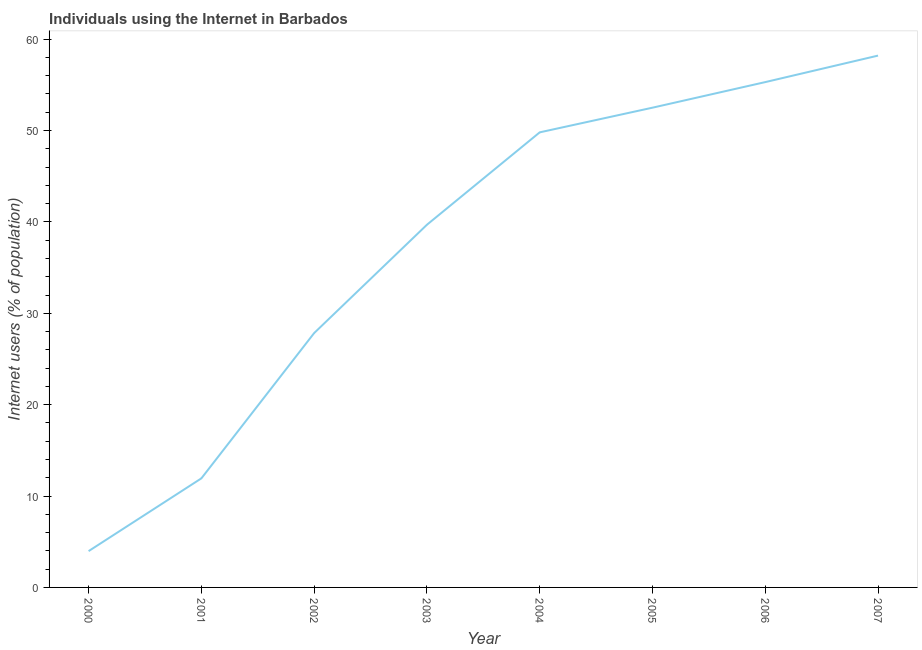What is the number of internet users in 2006?
Offer a very short reply. 55.3. Across all years, what is the maximum number of internet users?
Provide a succinct answer. 58.2. Across all years, what is the minimum number of internet users?
Provide a succinct answer. 3.97. In which year was the number of internet users maximum?
Make the answer very short. 2007. In which year was the number of internet users minimum?
Give a very brief answer. 2000. What is the sum of the number of internet users?
Give a very brief answer. 299.24. What is the difference between the number of internet users in 2001 and 2004?
Give a very brief answer. -37.86. What is the average number of internet users per year?
Offer a terse response. 37.4. What is the median number of internet users?
Your response must be concise. 44.74. In how many years, is the number of internet users greater than 8 %?
Keep it short and to the point. 7. What is the ratio of the number of internet users in 2002 to that in 2007?
Keep it short and to the point. 0.48. Is the number of internet users in 2000 less than that in 2002?
Keep it short and to the point. Yes. Is the difference between the number of internet users in 2004 and 2005 greater than the difference between any two years?
Make the answer very short. No. What is the difference between the highest and the second highest number of internet users?
Provide a short and direct response. 2.9. Is the sum of the number of internet users in 2004 and 2005 greater than the maximum number of internet users across all years?
Provide a short and direct response. Yes. What is the difference between the highest and the lowest number of internet users?
Your answer should be very brief. 54.23. Does the number of internet users monotonically increase over the years?
Your answer should be compact. Yes. How many lines are there?
Your response must be concise. 1. How many years are there in the graph?
Give a very brief answer. 8. Are the values on the major ticks of Y-axis written in scientific E-notation?
Keep it short and to the point. No. Does the graph contain grids?
Your response must be concise. No. What is the title of the graph?
Provide a short and direct response. Individuals using the Internet in Barbados. What is the label or title of the Y-axis?
Your answer should be compact. Internet users (% of population). What is the Internet users (% of population) in 2000?
Give a very brief answer. 3.97. What is the Internet users (% of population) in 2001?
Offer a very short reply. 11.94. What is the Internet users (% of population) of 2002?
Provide a succinct answer. 27.84. What is the Internet users (% of population) of 2003?
Make the answer very short. 39.69. What is the Internet users (% of population) in 2004?
Your response must be concise. 49.8. What is the Internet users (% of population) in 2005?
Keep it short and to the point. 52.5. What is the Internet users (% of population) in 2006?
Your answer should be compact. 55.3. What is the Internet users (% of population) of 2007?
Offer a terse response. 58.2. What is the difference between the Internet users (% of population) in 2000 and 2001?
Give a very brief answer. -7.96. What is the difference between the Internet users (% of population) in 2000 and 2002?
Ensure brevity in your answer.  -23.86. What is the difference between the Internet users (% of population) in 2000 and 2003?
Provide a short and direct response. -35.72. What is the difference between the Internet users (% of population) in 2000 and 2004?
Give a very brief answer. -45.83. What is the difference between the Internet users (% of population) in 2000 and 2005?
Your answer should be compact. -48.53. What is the difference between the Internet users (% of population) in 2000 and 2006?
Your answer should be very brief. -51.33. What is the difference between the Internet users (% of population) in 2000 and 2007?
Ensure brevity in your answer.  -54.23. What is the difference between the Internet users (% of population) in 2001 and 2002?
Your response must be concise. -15.9. What is the difference between the Internet users (% of population) in 2001 and 2003?
Make the answer very short. -27.75. What is the difference between the Internet users (% of population) in 2001 and 2004?
Your answer should be compact. -37.86. What is the difference between the Internet users (% of population) in 2001 and 2005?
Give a very brief answer. -40.56. What is the difference between the Internet users (% of population) in 2001 and 2006?
Provide a succinct answer. -43.36. What is the difference between the Internet users (% of population) in 2001 and 2007?
Make the answer very short. -46.26. What is the difference between the Internet users (% of population) in 2002 and 2003?
Provide a short and direct response. -11.85. What is the difference between the Internet users (% of population) in 2002 and 2004?
Your answer should be very brief. -21.96. What is the difference between the Internet users (% of population) in 2002 and 2005?
Your answer should be compact. -24.66. What is the difference between the Internet users (% of population) in 2002 and 2006?
Keep it short and to the point. -27.46. What is the difference between the Internet users (% of population) in 2002 and 2007?
Make the answer very short. -30.36. What is the difference between the Internet users (% of population) in 2003 and 2004?
Ensure brevity in your answer.  -10.11. What is the difference between the Internet users (% of population) in 2003 and 2005?
Provide a succinct answer. -12.81. What is the difference between the Internet users (% of population) in 2003 and 2006?
Provide a succinct answer. -15.61. What is the difference between the Internet users (% of population) in 2003 and 2007?
Your answer should be compact. -18.51. What is the difference between the Internet users (% of population) in 2004 and 2005?
Offer a terse response. -2.7. What is the difference between the Internet users (% of population) in 2005 and 2006?
Ensure brevity in your answer.  -2.8. What is the ratio of the Internet users (% of population) in 2000 to that in 2001?
Your answer should be very brief. 0.33. What is the ratio of the Internet users (% of population) in 2000 to that in 2002?
Your answer should be compact. 0.14. What is the ratio of the Internet users (% of population) in 2000 to that in 2003?
Your answer should be very brief. 0.1. What is the ratio of the Internet users (% of population) in 2000 to that in 2005?
Ensure brevity in your answer.  0.08. What is the ratio of the Internet users (% of population) in 2000 to that in 2006?
Provide a succinct answer. 0.07. What is the ratio of the Internet users (% of population) in 2000 to that in 2007?
Make the answer very short. 0.07. What is the ratio of the Internet users (% of population) in 2001 to that in 2002?
Make the answer very short. 0.43. What is the ratio of the Internet users (% of population) in 2001 to that in 2003?
Provide a short and direct response. 0.3. What is the ratio of the Internet users (% of population) in 2001 to that in 2004?
Offer a terse response. 0.24. What is the ratio of the Internet users (% of population) in 2001 to that in 2005?
Your answer should be very brief. 0.23. What is the ratio of the Internet users (% of population) in 2001 to that in 2006?
Your answer should be compact. 0.22. What is the ratio of the Internet users (% of population) in 2001 to that in 2007?
Make the answer very short. 0.2. What is the ratio of the Internet users (% of population) in 2002 to that in 2003?
Offer a terse response. 0.7. What is the ratio of the Internet users (% of population) in 2002 to that in 2004?
Ensure brevity in your answer.  0.56. What is the ratio of the Internet users (% of population) in 2002 to that in 2005?
Give a very brief answer. 0.53. What is the ratio of the Internet users (% of population) in 2002 to that in 2006?
Provide a short and direct response. 0.5. What is the ratio of the Internet users (% of population) in 2002 to that in 2007?
Give a very brief answer. 0.48. What is the ratio of the Internet users (% of population) in 2003 to that in 2004?
Give a very brief answer. 0.8. What is the ratio of the Internet users (% of population) in 2003 to that in 2005?
Your answer should be very brief. 0.76. What is the ratio of the Internet users (% of population) in 2003 to that in 2006?
Make the answer very short. 0.72. What is the ratio of the Internet users (% of population) in 2003 to that in 2007?
Give a very brief answer. 0.68. What is the ratio of the Internet users (% of population) in 2004 to that in 2005?
Keep it short and to the point. 0.95. What is the ratio of the Internet users (% of population) in 2004 to that in 2006?
Make the answer very short. 0.9. What is the ratio of the Internet users (% of population) in 2004 to that in 2007?
Give a very brief answer. 0.86. What is the ratio of the Internet users (% of population) in 2005 to that in 2006?
Ensure brevity in your answer.  0.95. What is the ratio of the Internet users (% of population) in 2005 to that in 2007?
Offer a very short reply. 0.9. What is the ratio of the Internet users (% of population) in 2006 to that in 2007?
Give a very brief answer. 0.95. 